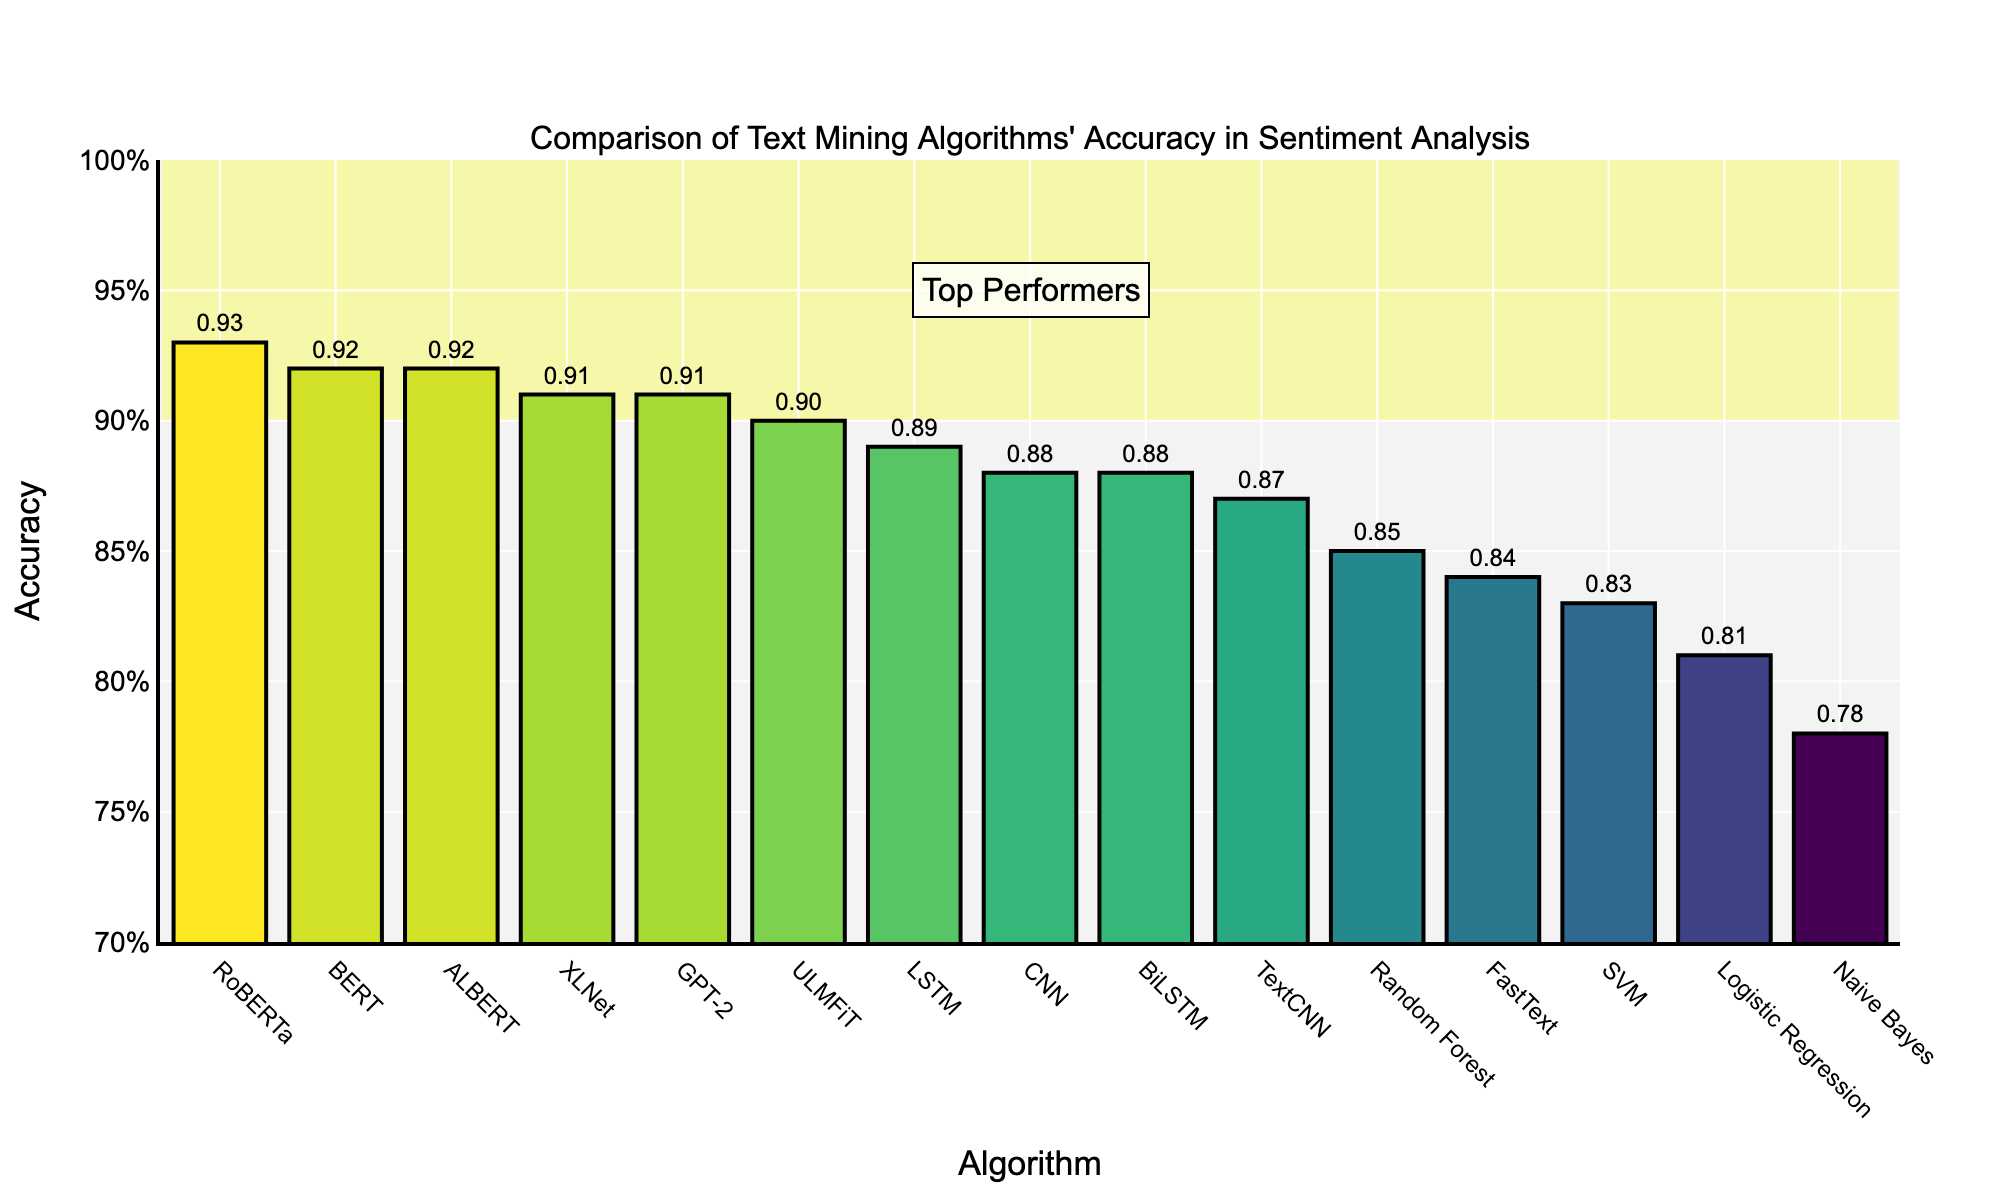Which algorithm has the highest accuracy in sentiment analysis? By sorting the algorithms by their accuracy values, RoBERTa has the highest accuracy at 0.93.
Answer: RoBERTa Which algorithms have an accuracy of 0.92 or higher? Looking at the algorithms with accuracy values, BERT, RoBERTa, ALBERT, and GPT-2 meet this criterion.
Answer: BERT, RoBERTa, ALBERT, GPT-2 How does FastText compare to Random Forest in terms of accuracy? FastText has an accuracy of 0.84, while Random Forest has an accuracy of 0.85. Since 0.84 is less than 0.85, FastText is slightly less accurate than Random Forest.
Answer: Random Forest is more accurate than FastText Which algorithm has the lowest accuracy, and what is its value? By examining the accuracy values, Naive Bayes has the lowest accuracy at 0.78.
Answer: Naive Bayes, 0.78 How many algorithms have an accuracy of 0.90 or above? Count the number of algorithms with accuracy values of 0.90 or higher: BERT, XLNet, LSTM, RoBERTa, ULMFiT, GPT-2, and ALBERT. This results in seven algorithms.
Answer: 7 What is the difference in accuracy between CNN and BiLSTM? CNN has an accuracy of 0.88, and BiLSTM also has an accuracy of 0.88. The difference in their accuracy is 0.00.
Answer: 0.00 Which algorithms fall into the range of 0.85 to 0.90 accuracy? Algorithms within this range include Random Forest (0.85), CNN (0.88), BiLSTM (0.88), TextCNN (0.87), and ULMFiT (0.90).
Answer: Random Forest, CNN, BiLSTM, TextCNN, ULMFiT Which algorithms are highlighted as top performers in the figure? The highlighted top performers are those with an accuracy of 0.90 and above, including BERT, XLNet, LSTM, RoBERTa, ULMFiT, GPT-2, and ALBERT.
Answer: BERT, XLNet, LSTM, RoBERTa, ULMFiT, GPT-2, ALBERT What is the visual representation used to distinguish the top performers? The top performers are highlighted with a yellow rectangle in the background spanning the accuracy range from 0.90 to 1.00 on the y-axis.
Answer: Yellow rectangle 